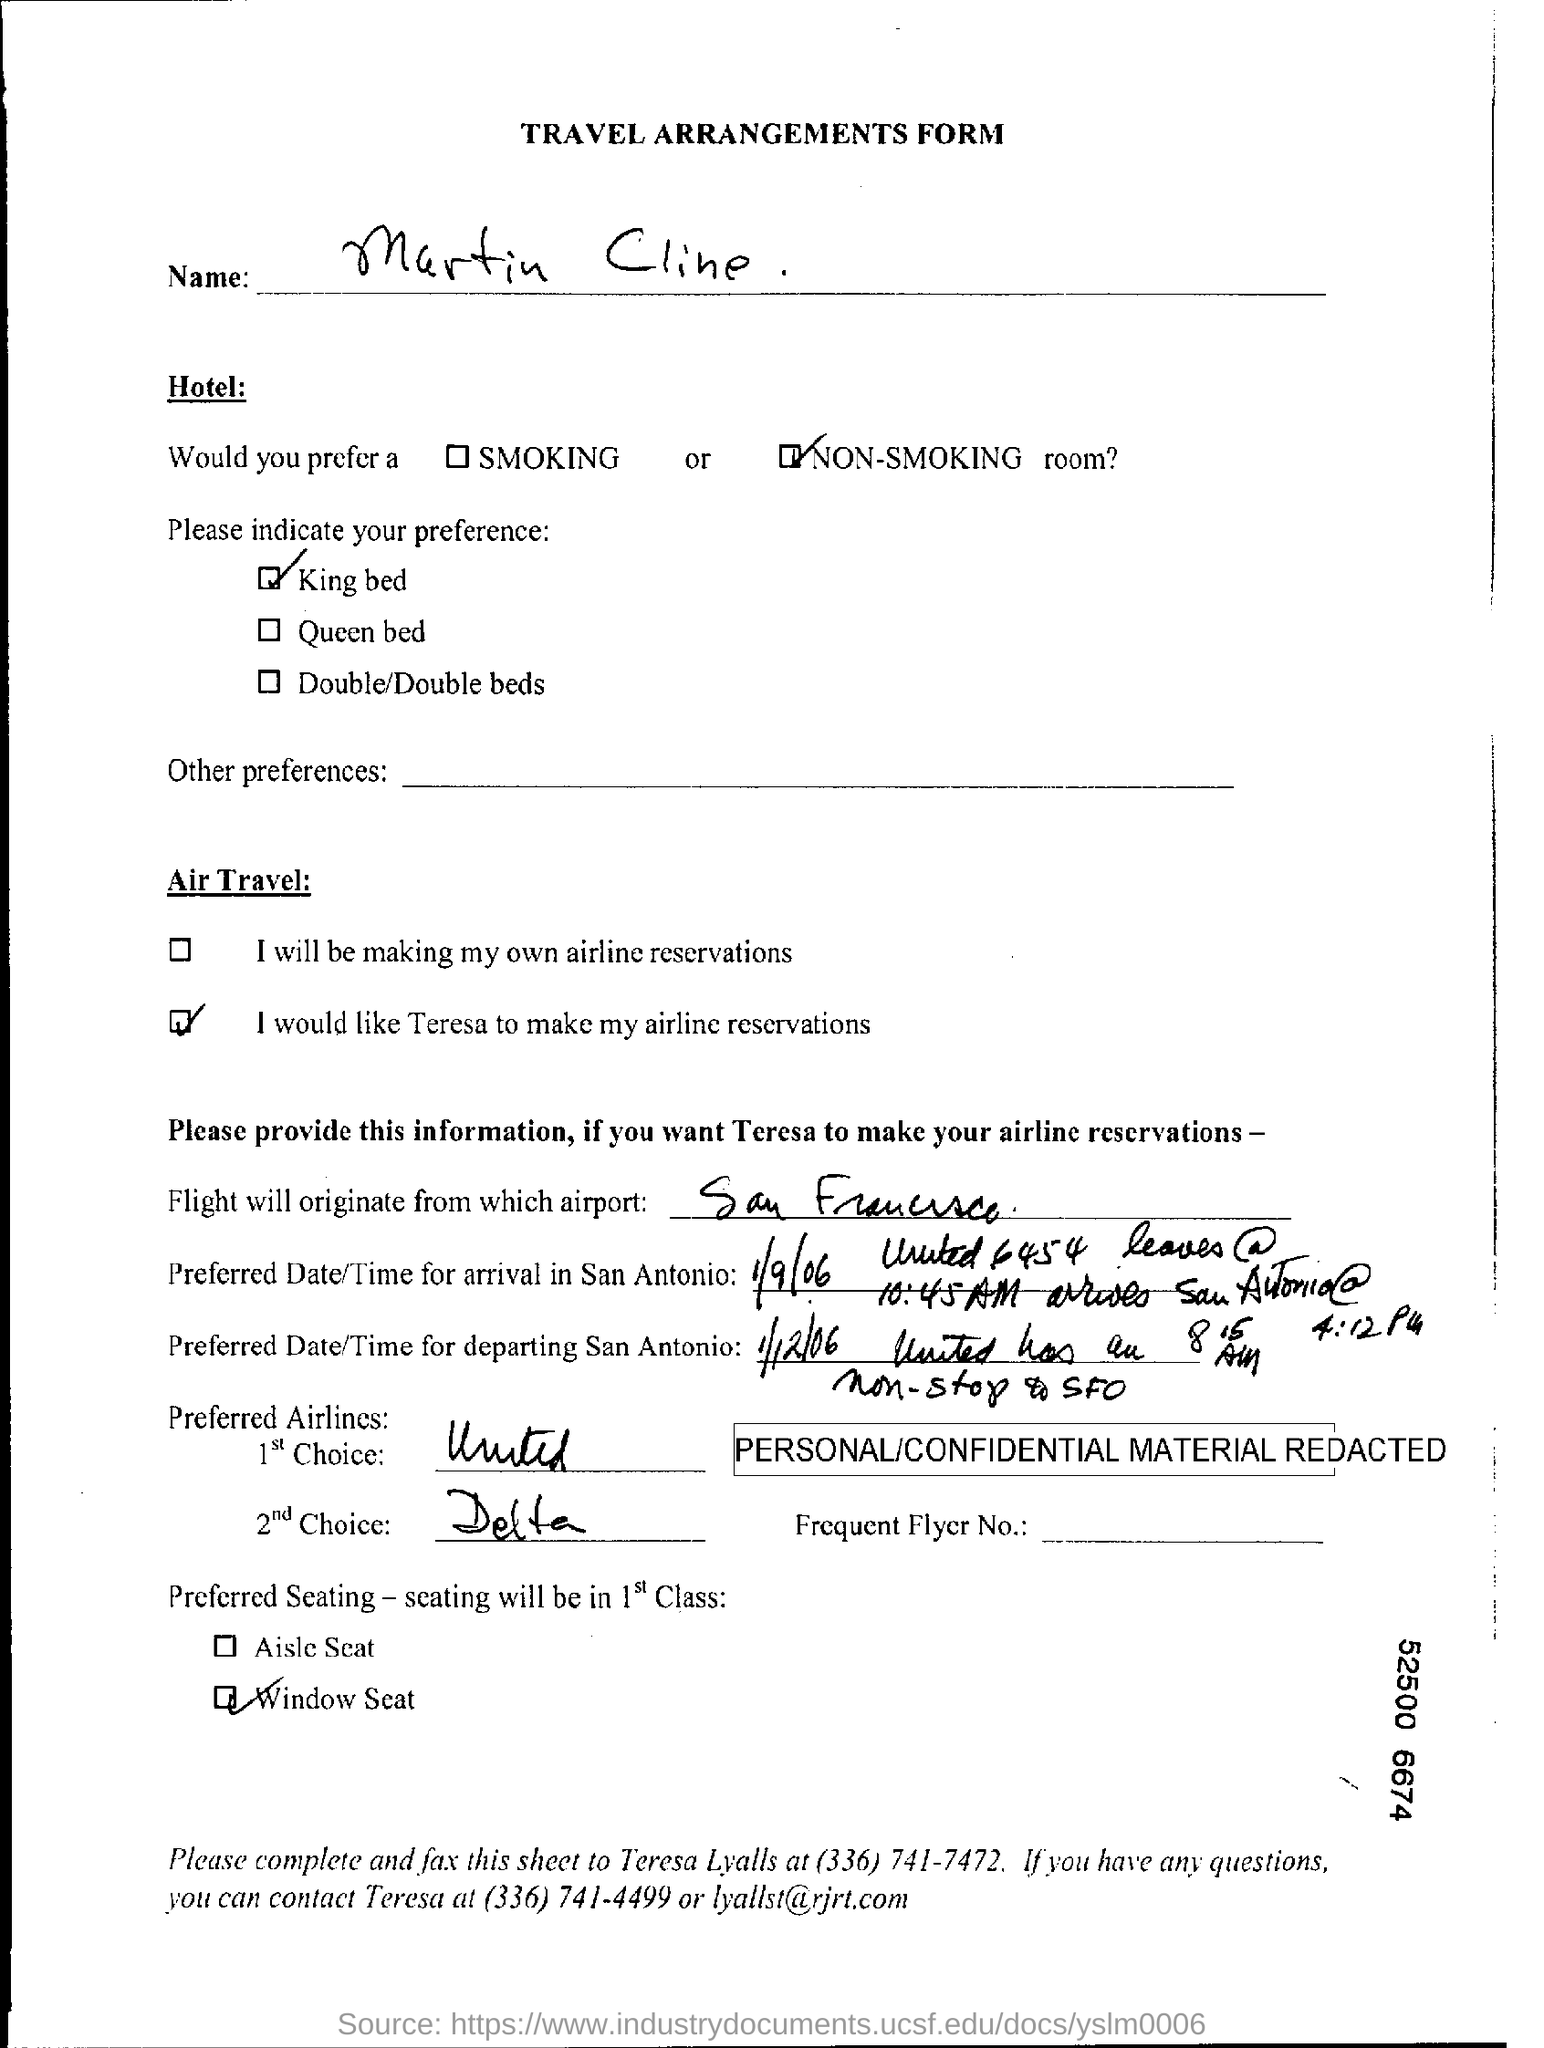Point out several critical features in this image. First class passengers typically prefer to sit in window seats. I prefer to stay in a non-smoking hotel. The second choice among Preferred airways is Delta. The flight will depart from San Francisco International Airport. It is the preferred type of bed that is known as a King Bed. 